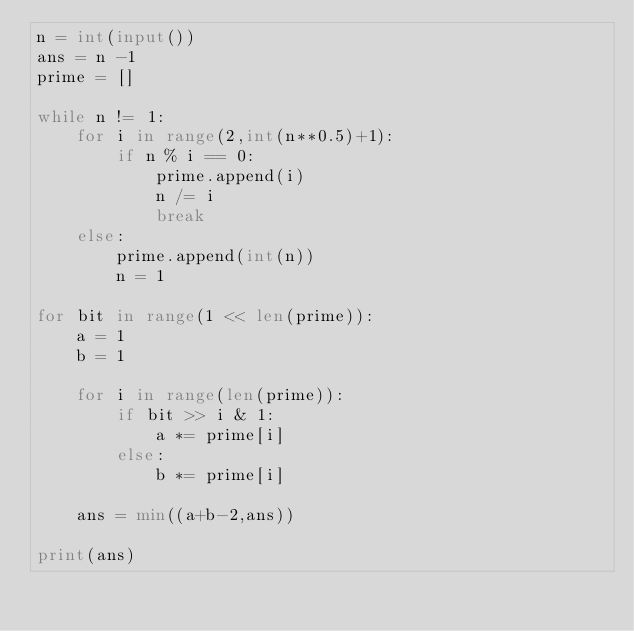<code> <loc_0><loc_0><loc_500><loc_500><_Python_>n = int(input())
ans = n -1
prime = []

while n != 1:
    for i in range(2,int(n**0.5)+1):
        if n % i == 0:
            prime.append(i)
            n /= i
            break
    else:
        prime.append(int(n))
        n = 1

for bit in range(1 << len(prime)):
    a = 1
    b = 1

    for i in range(len(prime)):
        if bit >> i & 1:
            a *= prime[i]
        else:
            b *= prime[i]

    ans = min((a+b-2,ans))

print(ans)</code> 